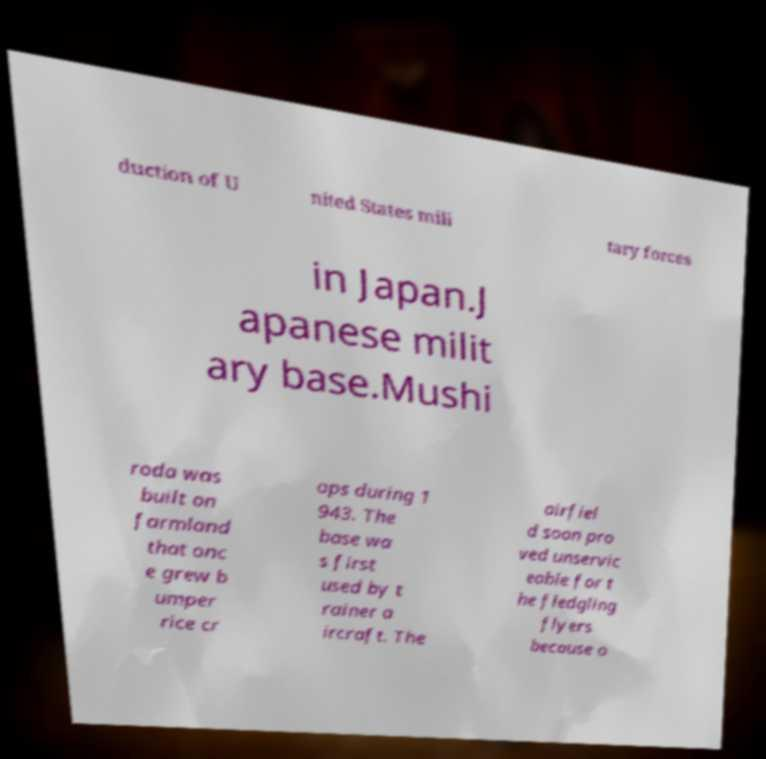There's text embedded in this image that I need extracted. Can you transcribe it verbatim? duction of U nited States mili tary forces in Japan.J apanese milit ary base.Mushi roda was built on farmland that onc e grew b umper rice cr ops during 1 943. The base wa s first used by t rainer a ircraft. The airfiel d soon pro ved unservic eable for t he fledgling flyers because o 